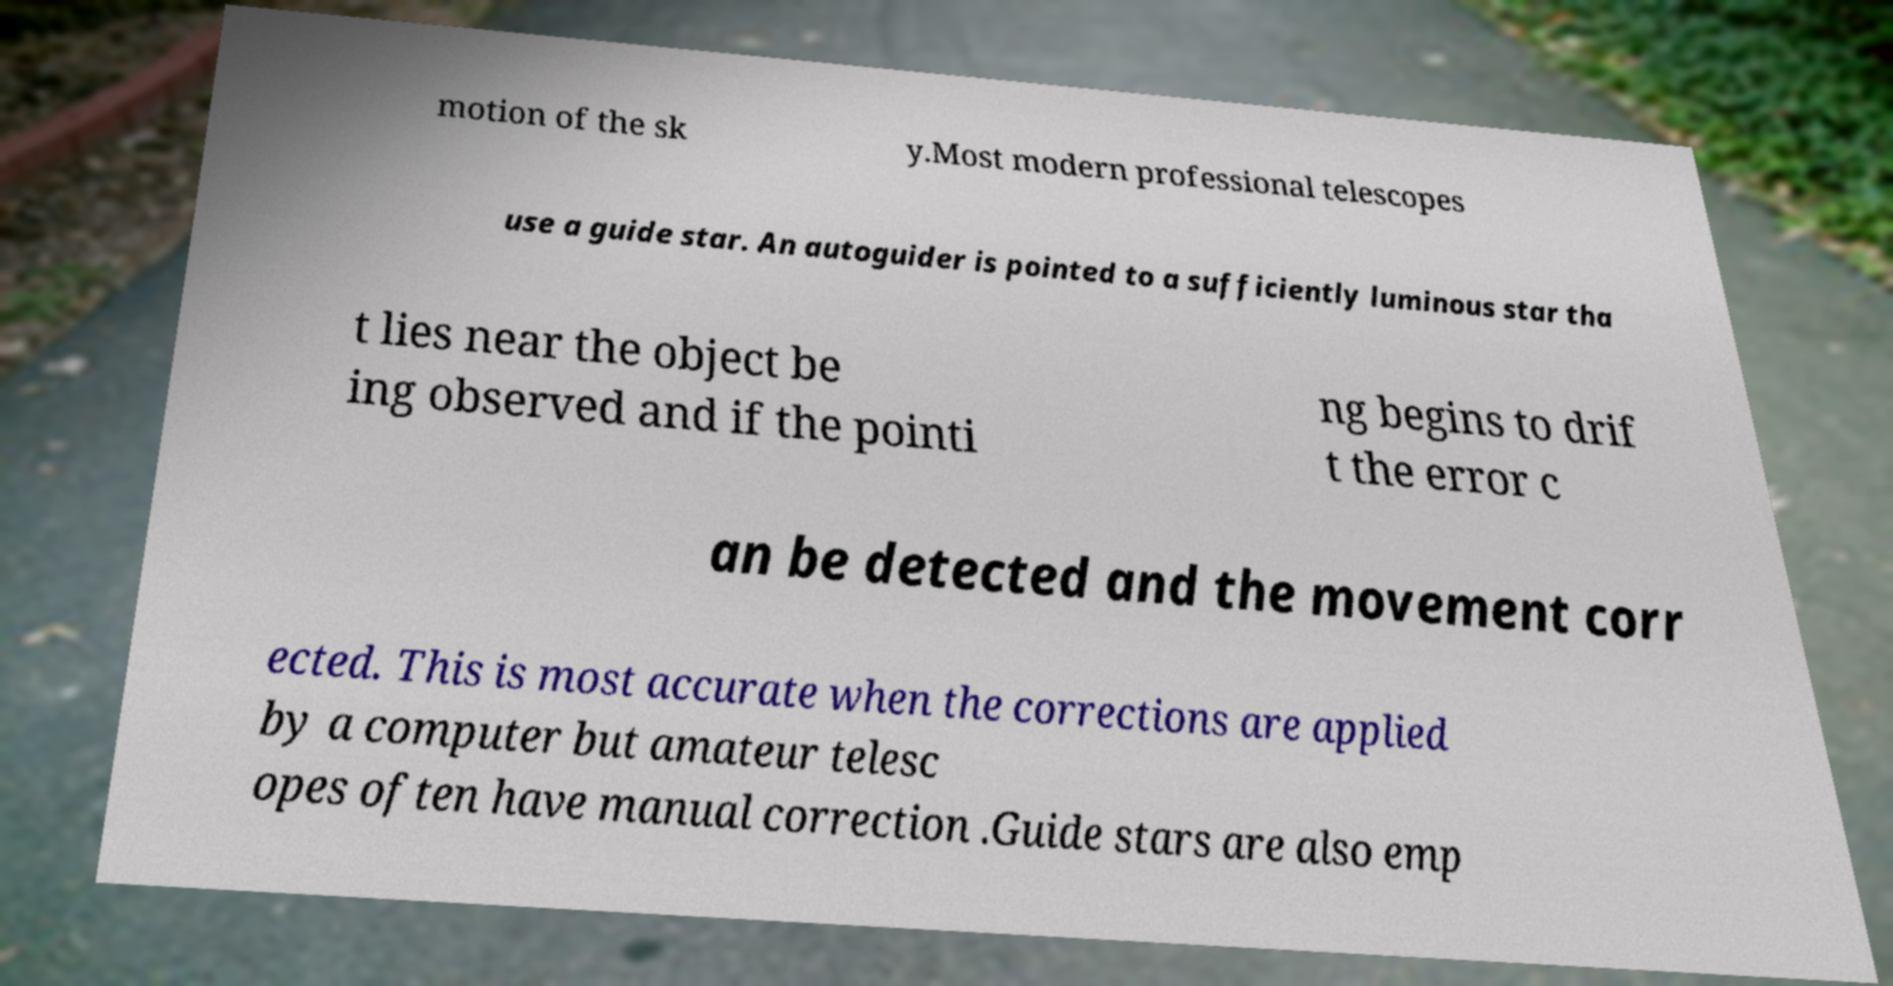Please identify and transcribe the text found in this image. motion of the sk y.Most modern professional telescopes use a guide star. An autoguider is pointed to a sufficiently luminous star tha t lies near the object be ing observed and if the pointi ng begins to drif t the error c an be detected and the movement corr ected. This is most accurate when the corrections are applied by a computer but amateur telesc opes often have manual correction .Guide stars are also emp 